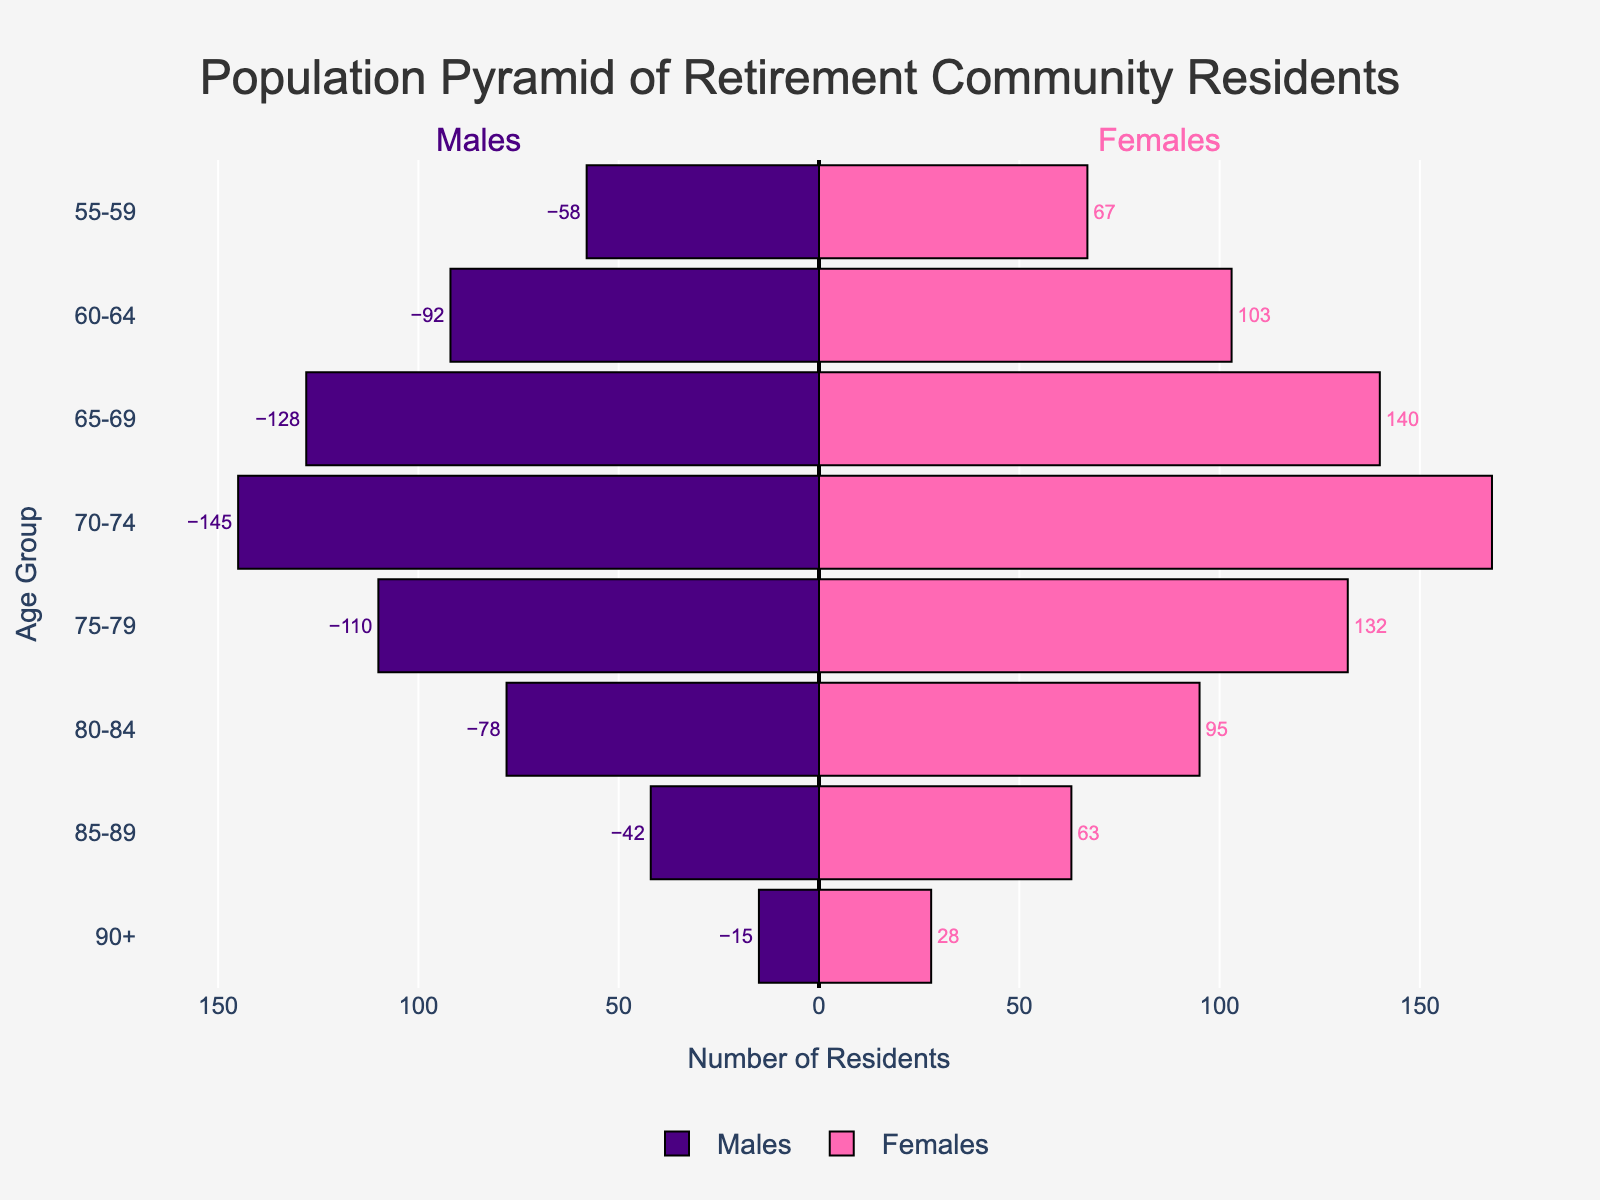How many males are there in the 75-79 age group? Look for the bar labeled "75-79" in the "Males" section and read the number.
Answer: 110 What is the overall difference between the number of males and females in the 90+ age group? Look at the values for both males and females in the "90+" age group. Compute the difference: 28 (females) - 15 (males).
Answer: 13 Which age group has the highest number of females? Identify the age group with the longest purple bar in the "Females" section. The 70-74 group has the longest bar.
Answer: 70-74 Compare the number of males in the 80-84 age group and the 85-89 age group. Which group has more? Observe the lengths of the bars for "Males" in the "80-84" and "85-89" age groups. The "80-84" group has a longer bar.
Answer: 80-84 What is the combined number of residents in the 60-64 age group? Sum the numbers for males and females in the "60-64" age group: 92 (males) + 103 (females) = 195.
Answer: 195 Which age group has almost an equal number of males and females? Compare the lengths of both bars for each age group and find the pair that are closest in length. The 65-69 group is almost equal.
Answer: 65-69 Between the 55-59 and 70-74 age groups, which has the greater difference in the number of residents between males and females? Calculate the differences for each age group: (67-58) for 55-59 and (168-145) for 70-74. The 70-74 age group has a greater difference.
Answer: 70-74 What is the range of the number of residents in the various age groups for males? Identify the smallest and largest values in the "Males" section and compute the range: 145 (70-74) - 15 (90+) = 130.
Answer: 130 